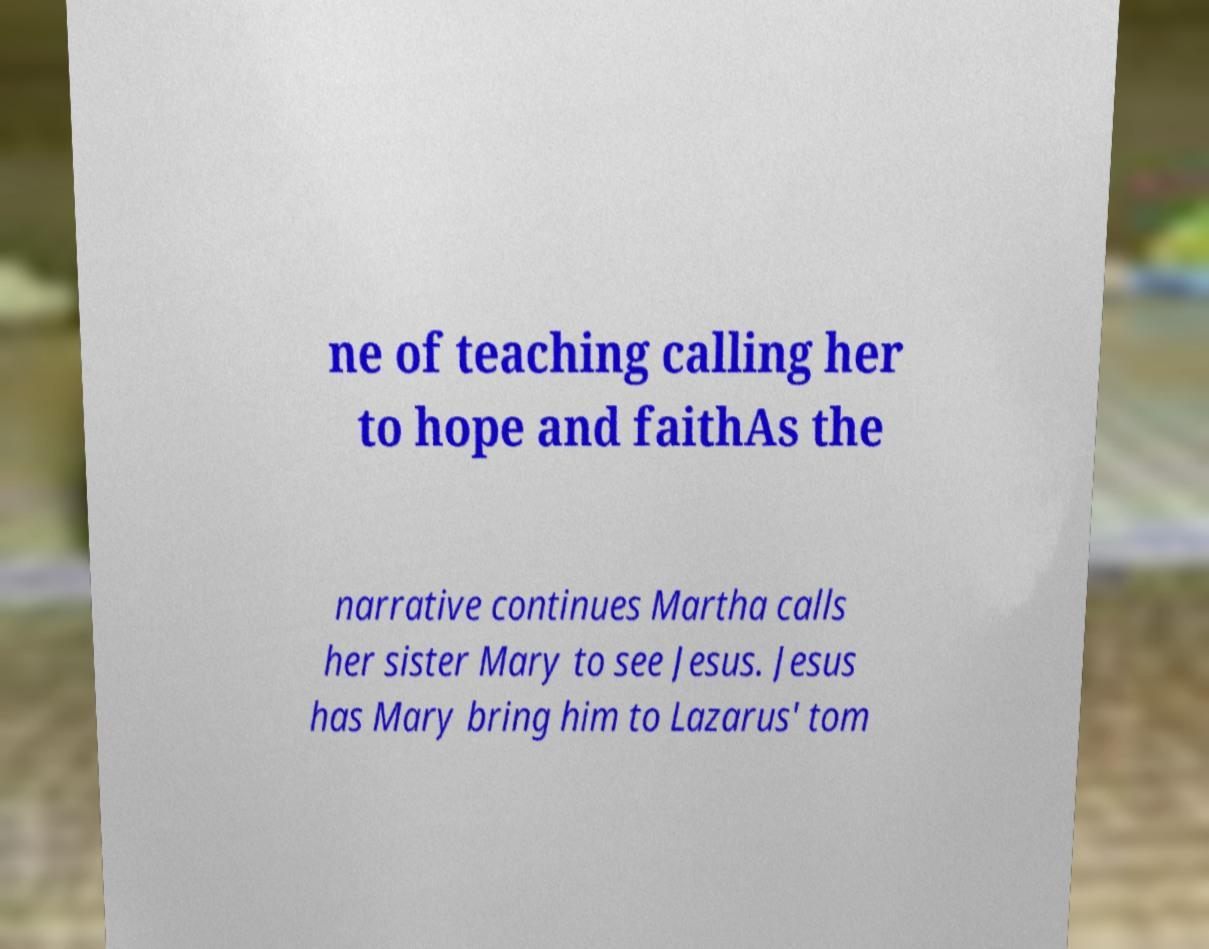Please read and relay the text visible in this image. What does it say? ne of teaching calling her to hope and faithAs the narrative continues Martha calls her sister Mary to see Jesus. Jesus has Mary bring him to Lazarus' tom 